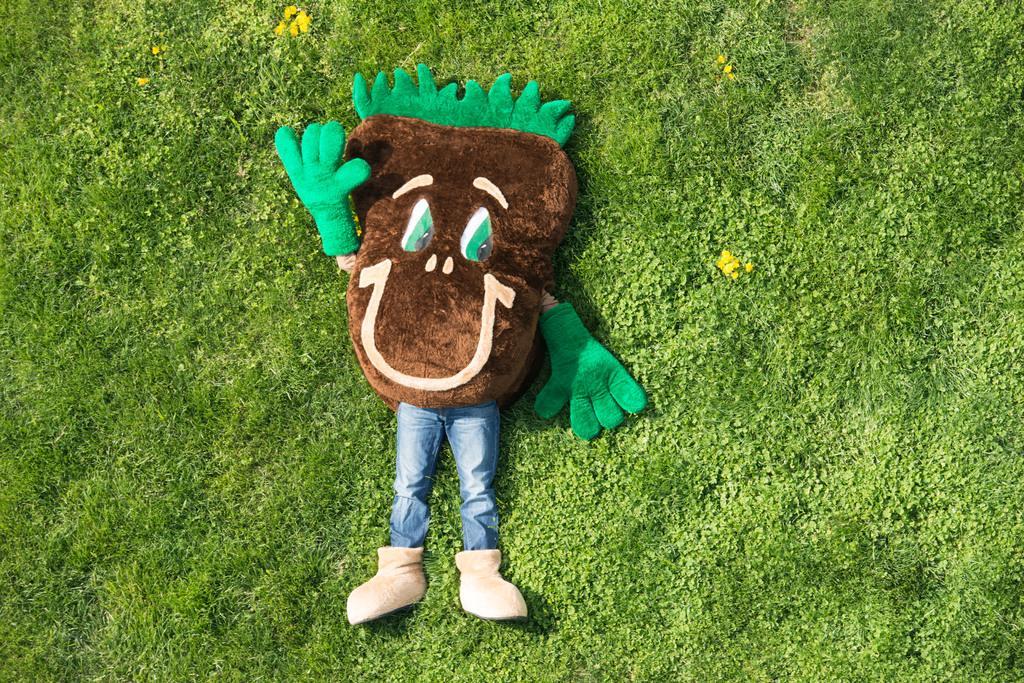In one or two sentences, can you explain what this image depicts? In the image there is a person with blue jeans and costume with brown and green color. And the person is wearing the shoes. The person is lying on the ground. On the ground there are small plants and grass. 